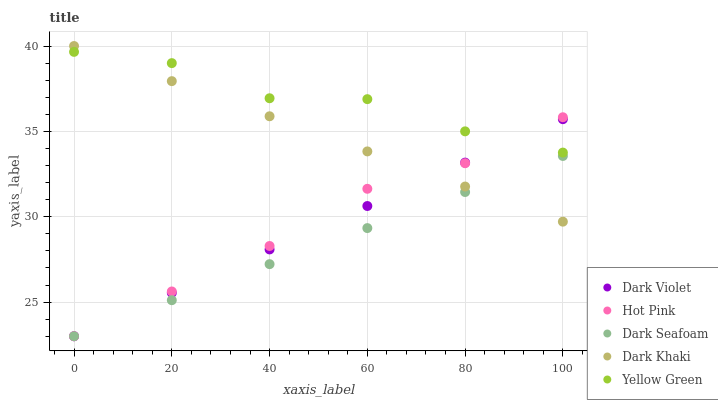Does Dark Seafoam have the minimum area under the curve?
Answer yes or no. Yes. Does Yellow Green have the maximum area under the curve?
Answer yes or no. Yes. Does Hot Pink have the minimum area under the curve?
Answer yes or no. No. Does Hot Pink have the maximum area under the curve?
Answer yes or no. No. Is Dark Khaki the smoothest?
Answer yes or no. Yes. Is Yellow Green the roughest?
Answer yes or no. Yes. Is Hot Pink the smoothest?
Answer yes or no. No. Is Hot Pink the roughest?
Answer yes or no. No. Does Dark Seafoam have the lowest value?
Answer yes or no. Yes. Does Yellow Green have the lowest value?
Answer yes or no. No. Does Dark Khaki have the highest value?
Answer yes or no. Yes. Does Hot Pink have the highest value?
Answer yes or no. No. Is Dark Seafoam less than Yellow Green?
Answer yes or no. Yes. Is Yellow Green greater than Dark Seafoam?
Answer yes or no. Yes. Does Dark Khaki intersect Dark Violet?
Answer yes or no. Yes. Is Dark Khaki less than Dark Violet?
Answer yes or no. No. Is Dark Khaki greater than Dark Violet?
Answer yes or no. No. Does Dark Seafoam intersect Yellow Green?
Answer yes or no. No. 